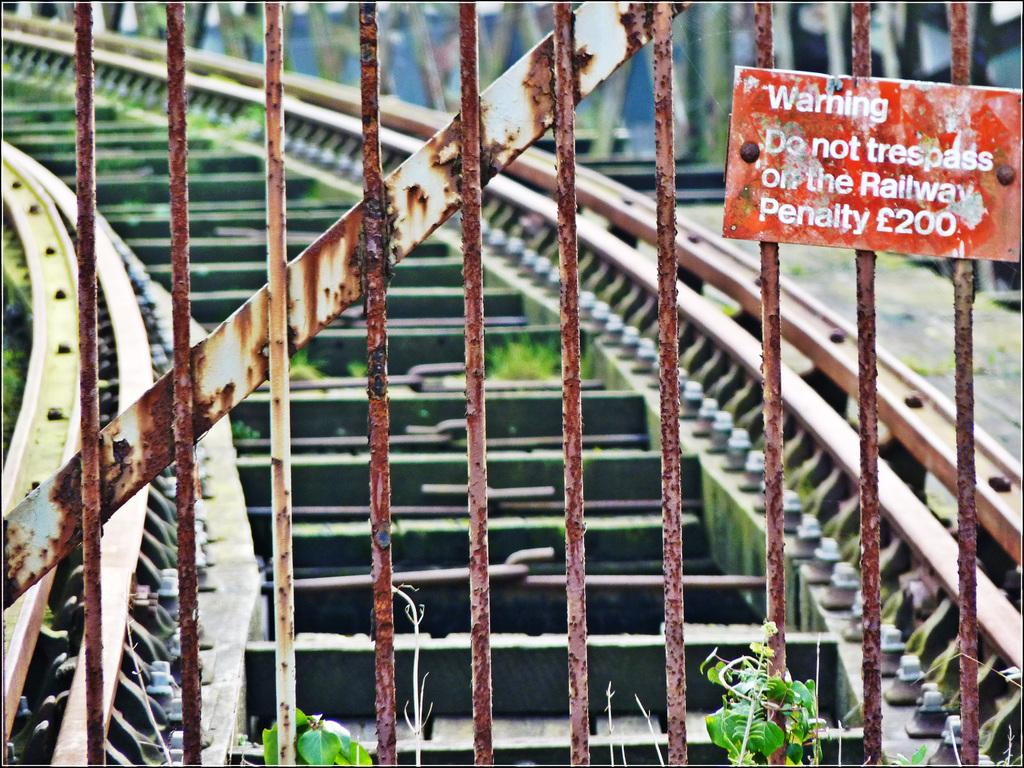What type of structure is present in the image? There is an iron gate in the image. Is there anything attached to the gate? Yes, there is a board attached to the gate. What can be found on the board? There is text or information on the board. What can be seen in the background of the image? There is a track visible in the background of the image. How would you describe the background of the image? The background of the image appears blurred. Can you see any goldfish swimming in the image? There are no goldfish present in the image. Is there a kitten playing with shoes in the image? There are no kittens or shoes present in the image. 